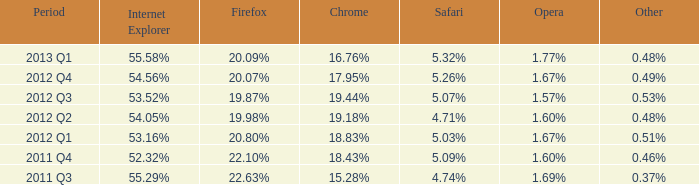Can you give me this table as a dict? {'header': ['Period', 'Internet Explorer', 'Firefox', 'Chrome', 'Safari', 'Opera', 'Other'], 'rows': [['2013 Q1', '55.58%', '20.09%', '16.76%', '5.32%', '1.77%', '0.48%'], ['2012 Q4', '54.56%', '20.07%', '17.95%', '5.26%', '1.67%', '0.49%'], ['2012 Q3', '53.52%', '19.87%', '19.44%', '5.07%', '1.57%', '0.53%'], ['2012 Q2', '54.05%', '19.98%', '19.18%', '4.71%', '1.60%', '0.48%'], ['2012 Q1', '53.16%', '20.80%', '18.83%', '5.03%', '1.67%', '0.51%'], ['2011 Q4', '52.32%', '22.10%', '18.43%', '5.09%', '1.60%', '0.46%'], ['2011 Q3', '55.29%', '22.63%', '15.28%', '4.74%', '1.69%', '0.37%']]} In the first quarter of 2012, which internet explorer had the same 1.67% market share as opera? 53.16%. 